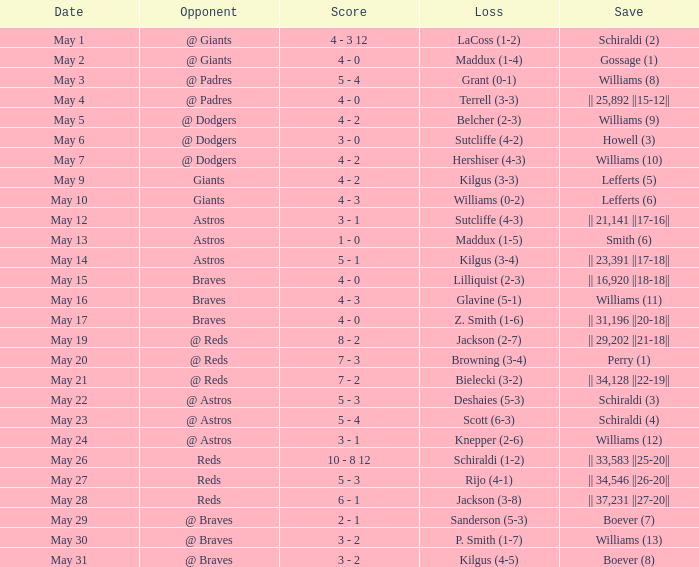Name the loss with save of || 23,391 ||17-18||? Kilgus (3-4). 